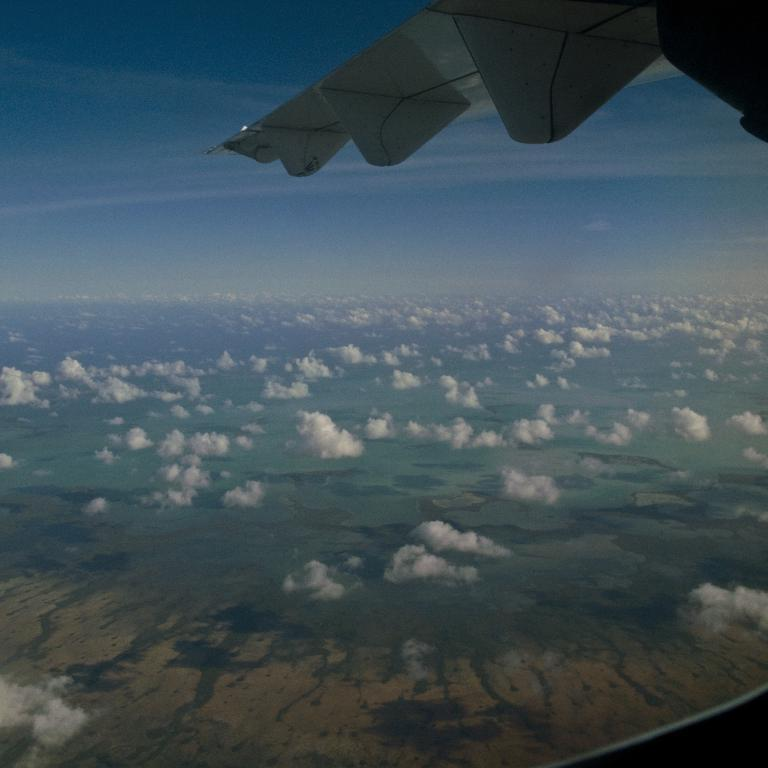What is the main subject of the image? The main subject of the image is a flying airplane. Where is the airplane located in relation to the clouds? The airplane is above the clouds in the image. Can you describe the landscape visible in the image? There is land visible in the image. How many chairs can be seen floating in the ocean in the image? There are no chairs or ocean present in the image; it features a flying airplane above the clouds. 